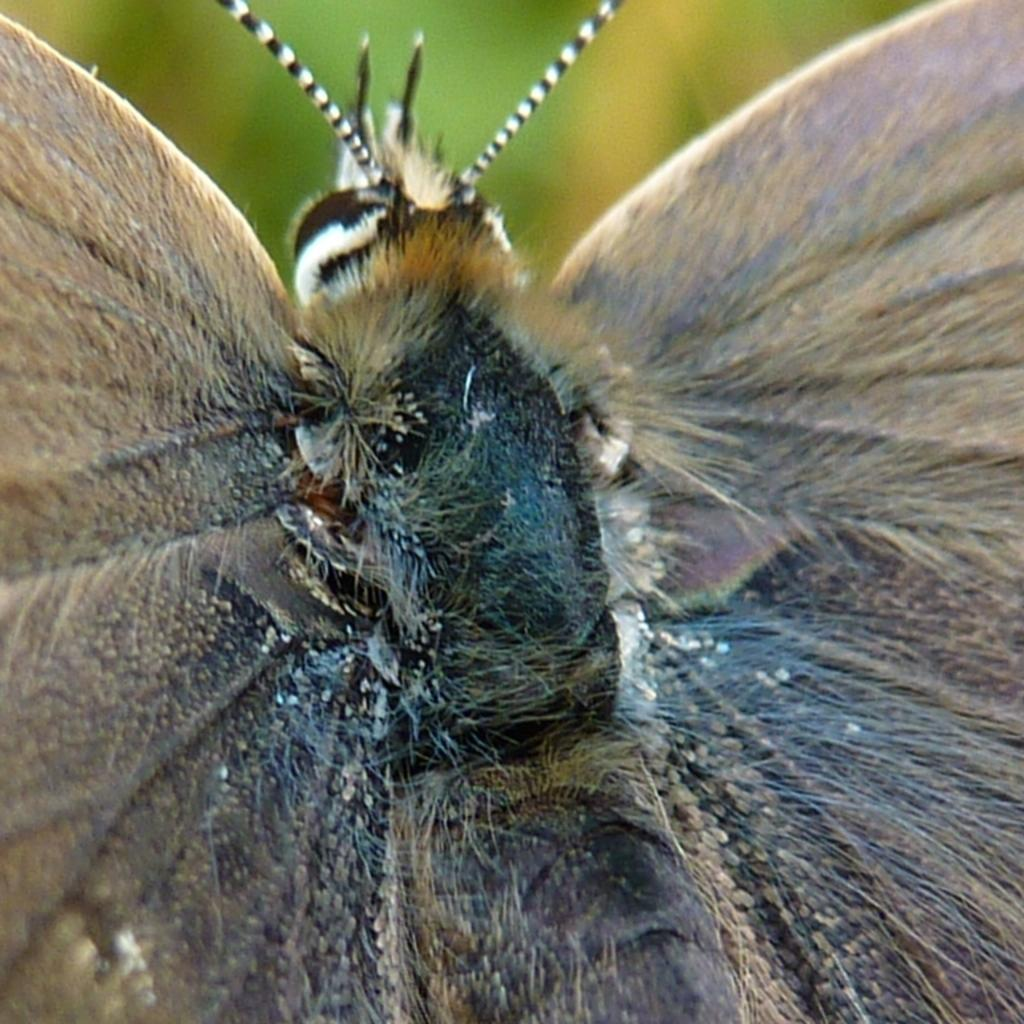What type of creature is present in the image? There is an insect in the image. Can you describe the coloring of the insect? The insect has black and brown coloring. What can be observed about the background of the image? The background of the image is blurred. Is there a pipe visible in the image? No, there is no pipe present in the image. Can you see a donkey in the image? No, there is no donkey present in the image. 